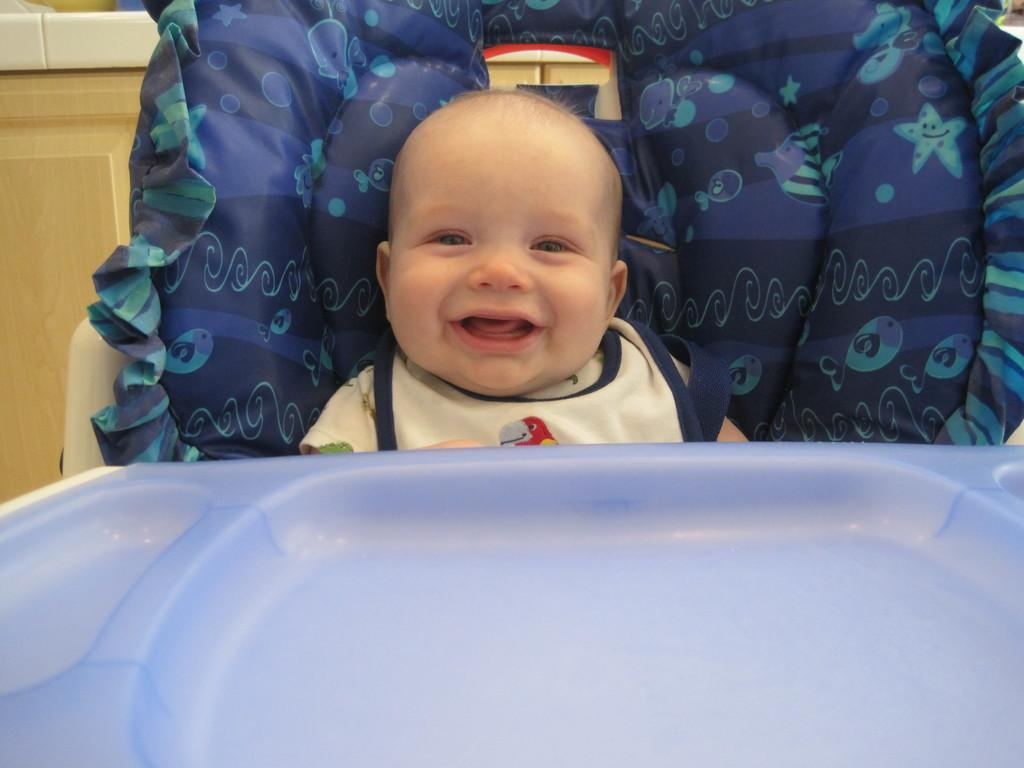What is the main subject of the image? The main subject of the image is a kid. What is the kid doing in the image? The kid is sitting in a wheel cart. What can be seen on the left side of the image? There is a closet door on the left side of the image. What is the kid's opinion on the current political climate in the image? There is no indication of the kid's opinion on the current political climate in the image. 